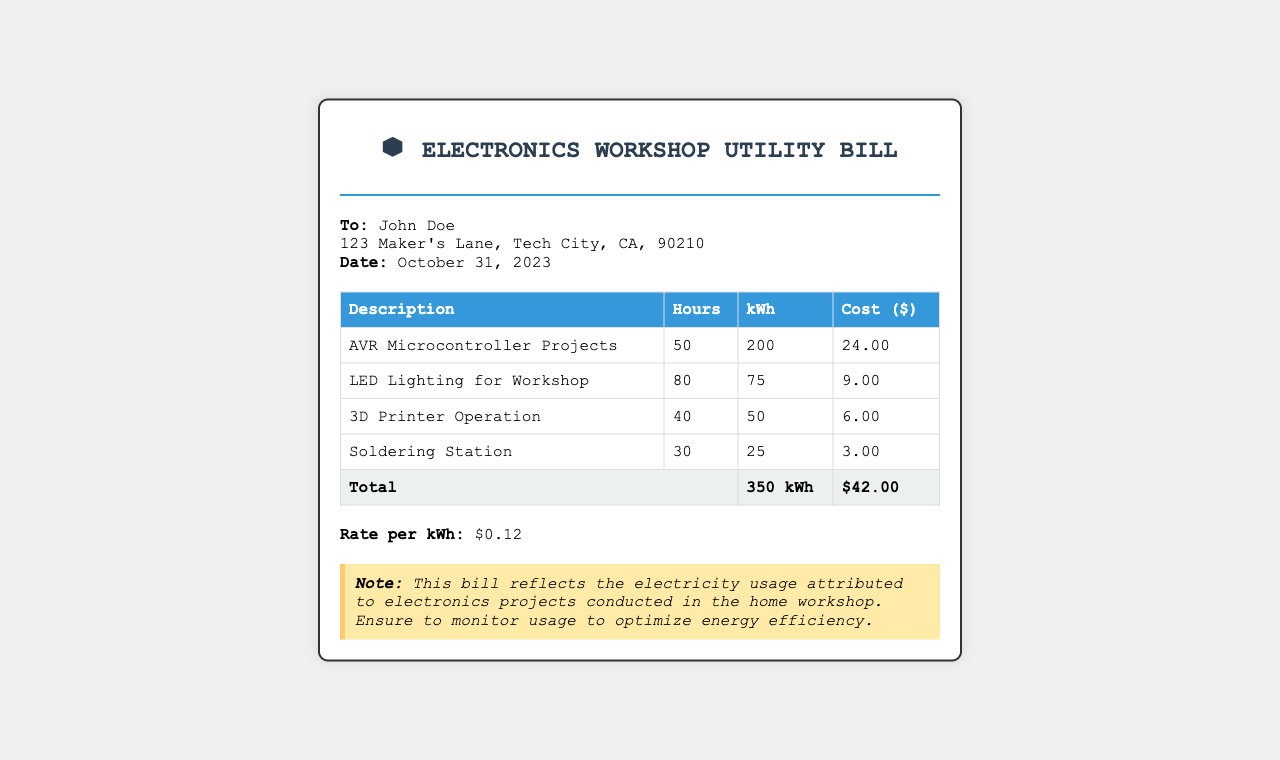What is the date of the utility bill? The document states the date issued for the utility bill is October 31, 2023.
Answer: October 31, 2023 Who is the recipient of the bill? The document clearly identifies the recipient of the bill as John Doe.
Answer: John Doe What is the total electricity usage? The total kWh used for the workshop electricity is summed from the itemized usage, which is 350 kWh.
Answer: 350 kWh What is the cost for the AVR Microcontroller Projects? The specific cost attributed to the AVR Microcontroller Projects is listed as $24.00 in the table.
Answer: $24.00 What is the rate per kWh? According to the document, the rate per kWh of electricity used is highlighted as $0.12.
Answer: $0.12 How many hours was the 3D Printer operated? The document specifies that the 3D Printer was operated for 40 hours.
Answer: 40 What is the total cost of the utility bill? The total cost, calculated from all the categories, amounts to $42.00 as noted in the document.
Answer: $42.00 Which project had the highest electricity usage? By reviewing the electricity usage breakdown, the AVR Microcontroller Projects had the highest usage at 200 kWh.
Answer: AVR Microcontroller Projects 